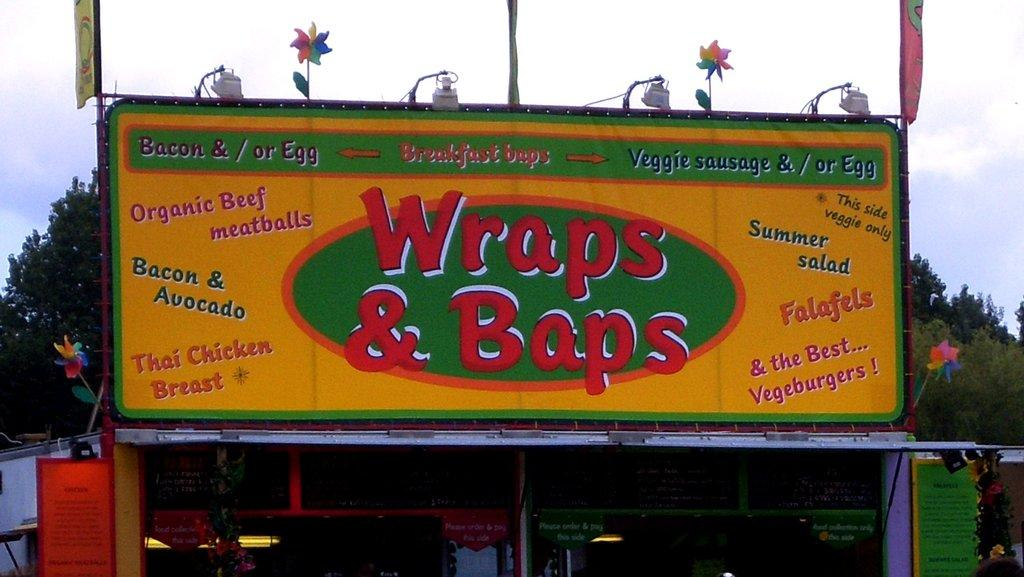<image>
Provide a brief description of the given image. A billboard sign that is yellow and green and says Wraps $ Baps in Red letters in the middle of the billboard. 